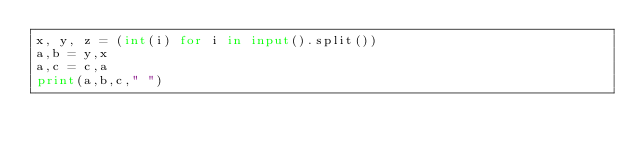<code> <loc_0><loc_0><loc_500><loc_500><_Python_>x, y, z = (int(i) for i in input().split())
a,b = y,x
a,c = c,a
print(a,b,c," ")
</code> 